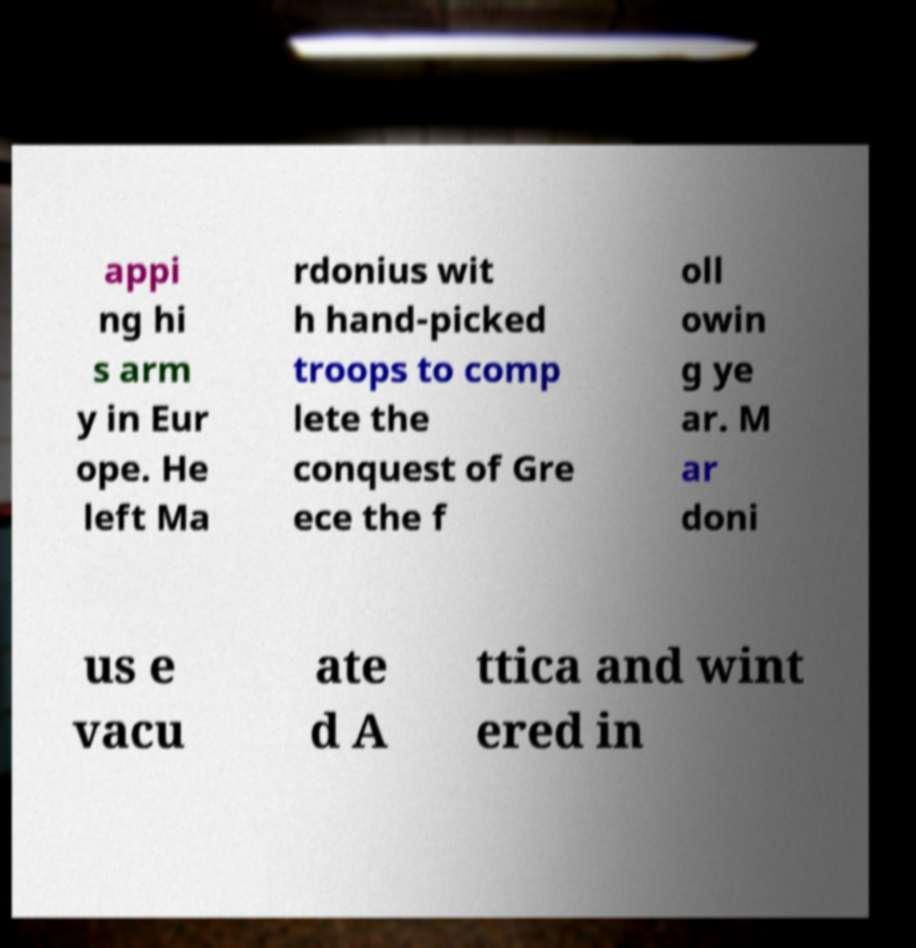Could you extract and type out the text from this image? appi ng hi s arm y in Eur ope. He left Ma rdonius wit h hand-picked troops to comp lete the conquest of Gre ece the f oll owin g ye ar. M ar doni us e vacu ate d A ttica and wint ered in 